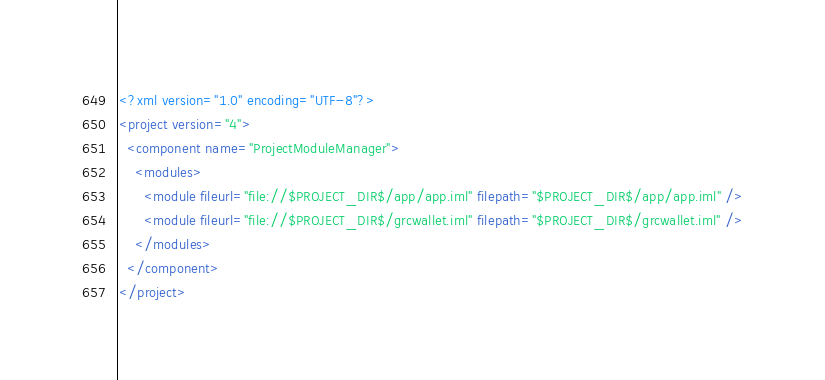Convert code to text. <code><loc_0><loc_0><loc_500><loc_500><_XML_><?xml version="1.0" encoding="UTF-8"?>
<project version="4">
  <component name="ProjectModuleManager">
    <modules>
      <module fileurl="file://$PROJECT_DIR$/app/app.iml" filepath="$PROJECT_DIR$/app/app.iml" />
      <module fileurl="file://$PROJECT_DIR$/grcwallet.iml" filepath="$PROJECT_DIR$/grcwallet.iml" />
    </modules>
  </component>
</project></code> 